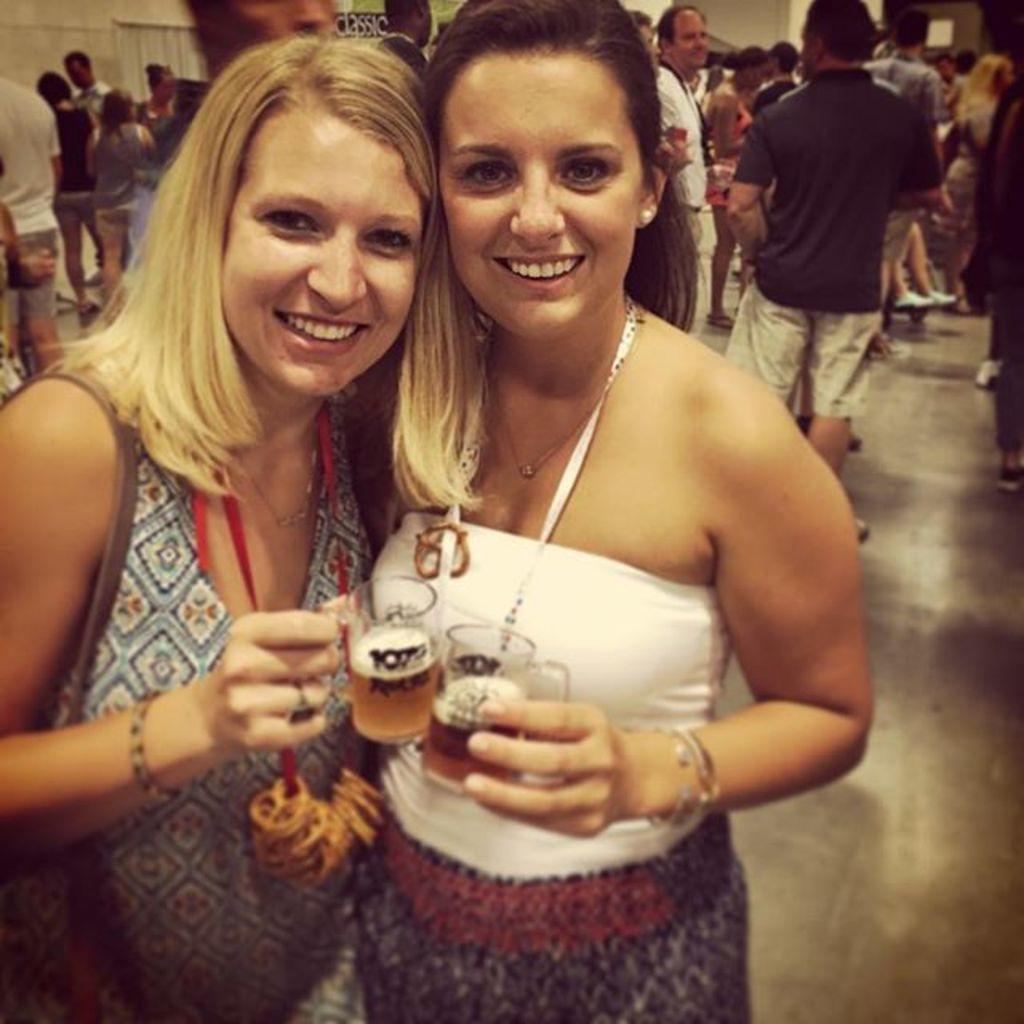Describe this image in one or two sentences. There are two women holding drinks in their hand and there are many people behind them. 